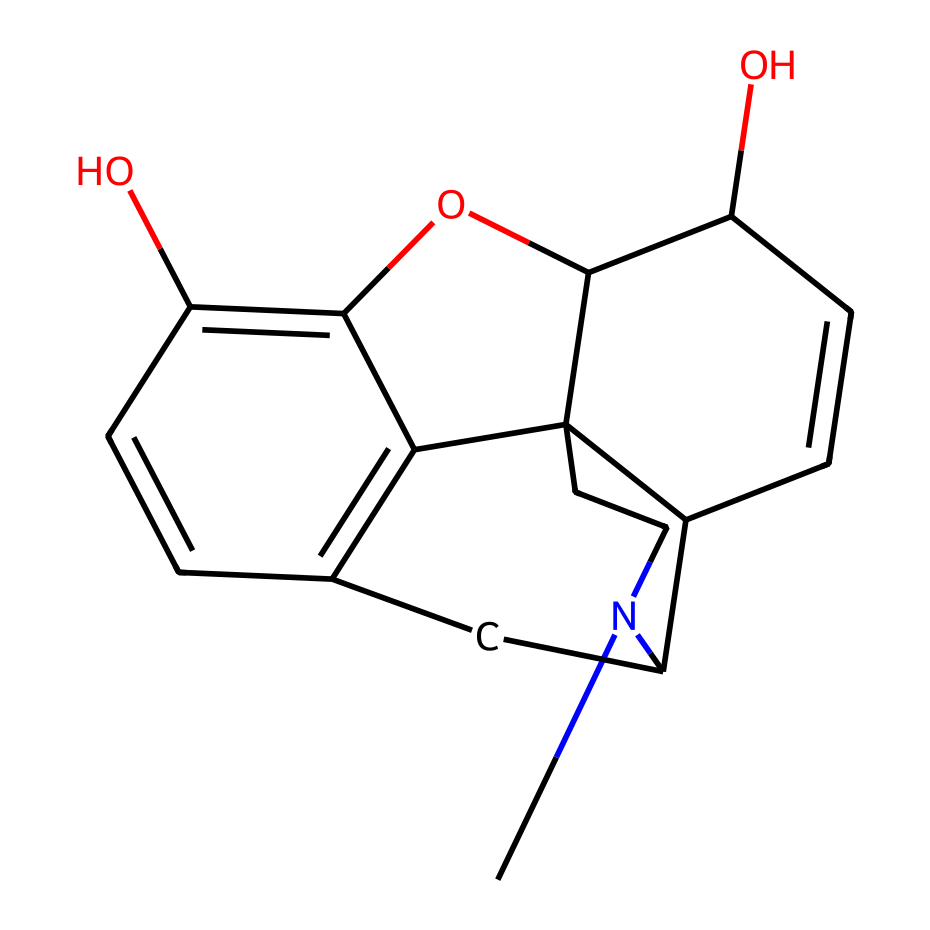What is the molecular formula of morphine? First, identify the elements present in the SMILES representation. The atoms are: C (carbon), H (hydrogen), and N (nitrogen). Count the occurrences: there are 17 carbons, 19 hydrogens, and 1 nitrogen. Thus, the molecular formula is C17H19N.
Answer: C17H19N How many rings are present in the structure of morphine? Analyzing the SMILES structure, we can see the numbers that indicate the ring connections (1, 2, 3, and 4 in the structure). Counting these indicates that there are 5 rings present in the morphine structure.
Answer: 5 What type of functional group is present in morphine? Reviewing the structure, we can identify hydroxyl (-OH) groups. There are two instances where OH groups are visible, which classifies morphine as a phenolic compound due to the presence of these hydroxyl groups attached to a carbon ring.
Answer: phenolic What is the total number of oxygen atoms in morphine? Inspecting the SMILES representation, we can specifically look for the letter "O" which indicates oxygen atoms. There are a total of 2 oxygen atoms within the morphine structure.
Answer: 2 What is the significance of the nitrogen atom in morphine? In organic compounds, especially in alkaloids like morphine, the presence of a nitrogen atom often indicates that the compound can be basic and interacts with neurotransmitter systems in the body. In this case, nitrogen contributes to morphine's role as an analgesic.
Answer: analgesic Is morphine a saturated or unsaturated compound? By analyzing the structure, we identify double bonds present in the carbon rings indicated by the absence of hydrogen in certain parts of the compound. This means that morphine contains double bonds among its carbon atoms, making it an unsaturated compound.
Answer: unsaturated 